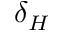Convert formula to latex. <formula><loc_0><loc_0><loc_500><loc_500>\delta _ { H }</formula> 